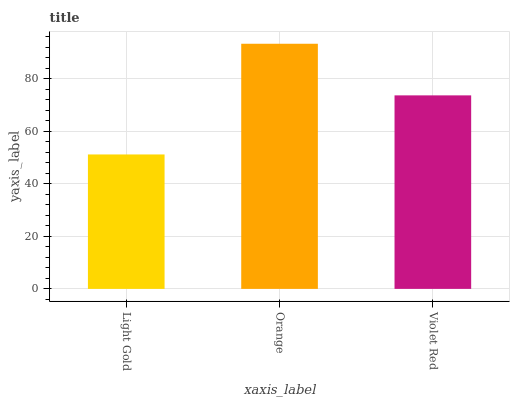Is Light Gold the minimum?
Answer yes or no. Yes. Is Orange the maximum?
Answer yes or no. Yes. Is Violet Red the minimum?
Answer yes or no. No. Is Violet Red the maximum?
Answer yes or no. No. Is Orange greater than Violet Red?
Answer yes or no. Yes. Is Violet Red less than Orange?
Answer yes or no. Yes. Is Violet Red greater than Orange?
Answer yes or no. No. Is Orange less than Violet Red?
Answer yes or no. No. Is Violet Red the high median?
Answer yes or no. Yes. Is Violet Red the low median?
Answer yes or no. Yes. Is Orange the high median?
Answer yes or no. No. Is Orange the low median?
Answer yes or no. No. 